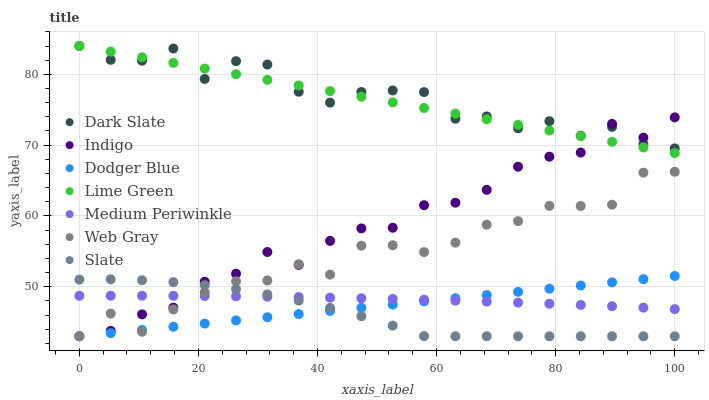Does Slate have the minimum area under the curve?
Answer yes or no. Yes. Does Dark Slate have the maximum area under the curve?
Answer yes or no. Yes. Does Indigo have the minimum area under the curve?
Answer yes or no. No. Does Indigo have the maximum area under the curve?
Answer yes or no. No. Is Dodger Blue the smoothest?
Answer yes or no. Yes. Is Dark Slate the roughest?
Answer yes or no. Yes. Is Indigo the smoothest?
Answer yes or no. No. Is Indigo the roughest?
Answer yes or no. No. Does Web Gray have the lowest value?
Answer yes or no. Yes. Does Medium Periwinkle have the lowest value?
Answer yes or no. No. Does Lime Green have the highest value?
Answer yes or no. Yes. Does Indigo have the highest value?
Answer yes or no. No. Is Slate less than Lime Green?
Answer yes or no. Yes. Is Lime Green greater than Dodger Blue?
Answer yes or no. Yes. Does Indigo intersect Medium Periwinkle?
Answer yes or no. Yes. Is Indigo less than Medium Periwinkle?
Answer yes or no. No. Is Indigo greater than Medium Periwinkle?
Answer yes or no. No. Does Slate intersect Lime Green?
Answer yes or no. No. 